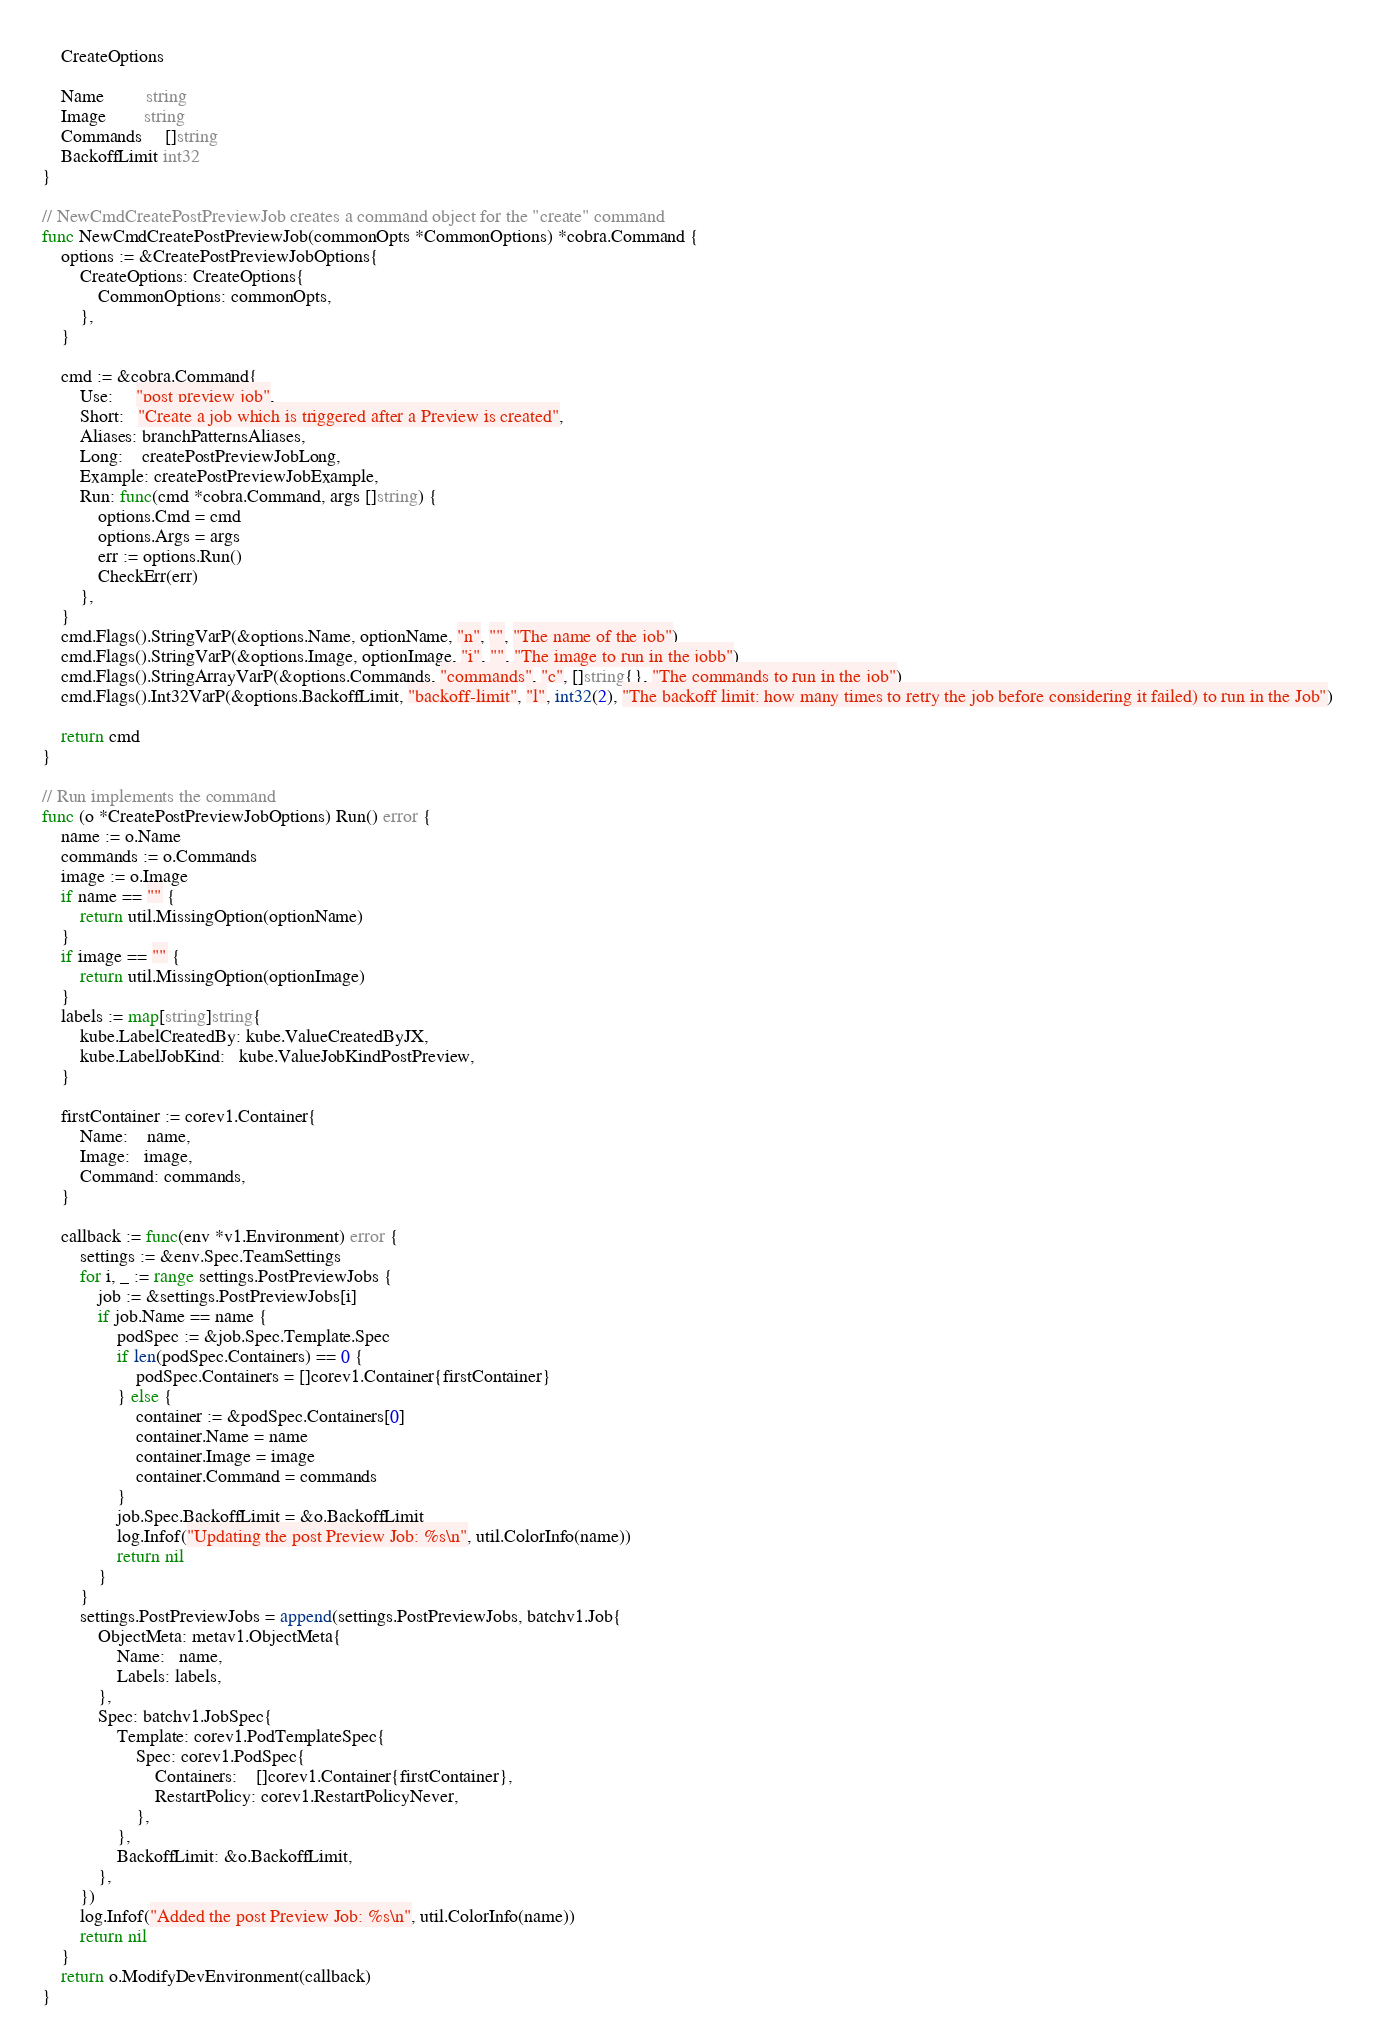Convert code to text. <code><loc_0><loc_0><loc_500><loc_500><_Go_>	CreateOptions

	Name         string
	Image        string
	Commands     []string
	BackoffLimit int32
}

// NewCmdCreatePostPreviewJob creates a command object for the "create" command
func NewCmdCreatePostPreviewJob(commonOpts *CommonOptions) *cobra.Command {
	options := &CreatePostPreviewJobOptions{
		CreateOptions: CreateOptions{
			CommonOptions: commonOpts,
		},
	}

	cmd := &cobra.Command{
		Use:     "post preview job",
		Short:   "Create a job which is triggered after a Preview is created",
		Aliases: branchPatternsAliases,
		Long:    createPostPreviewJobLong,
		Example: createPostPreviewJobExample,
		Run: func(cmd *cobra.Command, args []string) {
			options.Cmd = cmd
			options.Args = args
			err := options.Run()
			CheckErr(err)
		},
	}
	cmd.Flags().StringVarP(&options.Name, optionName, "n", "", "The name of the job")
	cmd.Flags().StringVarP(&options.Image, optionImage, "i", "", "The image to run in the jobb")
	cmd.Flags().StringArrayVarP(&options.Commands, "commands", "c", []string{}, "The commands to run in the job")
	cmd.Flags().Int32VarP(&options.BackoffLimit, "backoff-limit", "l", int32(2), "The backoff limit: how many times to retry the job before considering it failed) to run in the Job")

	return cmd
}

// Run implements the command
func (o *CreatePostPreviewJobOptions) Run() error {
	name := o.Name
	commands := o.Commands
	image := o.Image
	if name == "" {
		return util.MissingOption(optionName)
	}
	if image == "" {
		return util.MissingOption(optionImage)
	}
	labels := map[string]string{
		kube.LabelCreatedBy: kube.ValueCreatedByJX,
		kube.LabelJobKind:   kube.ValueJobKindPostPreview,
	}

	firstContainer := corev1.Container{
		Name:    name,
		Image:   image,
		Command: commands,
	}

	callback := func(env *v1.Environment) error {
		settings := &env.Spec.TeamSettings
		for i, _ := range settings.PostPreviewJobs {
			job := &settings.PostPreviewJobs[i]
			if job.Name == name {
				podSpec := &job.Spec.Template.Spec
				if len(podSpec.Containers) == 0 {
					podSpec.Containers = []corev1.Container{firstContainer}
				} else {
					container := &podSpec.Containers[0]
					container.Name = name
					container.Image = image
					container.Command = commands
				}
				job.Spec.BackoffLimit = &o.BackoffLimit
				log.Infof("Updating the post Preview Job: %s\n", util.ColorInfo(name))
				return nil
			}
		}
		settings.PostPreviewJobs = append(settings.PostPreviewJobs, batchv1.Job{
			ObjectMeta: metav1.ObjectMeta{
				Name:   name,
				Labels: labels,
			},
			Spec: batchv1.JobSpec{
				Template: corev1.PodTemplateSpec{
					Spec: corev1.PodSpec{
						Containers:    []corev1.Container{firstContainer},
						RestartPolicy: corev1.RestartPolicyNever,
					},
				},
				BackoffLimit: &o.BackoffLimit,
			},
		})
		log.Infof("Added the post Preview Job: %s\n", util.ColorInfo(name))
		return nil
	}
	return o.ModifyDevEnvironment(callback)
}
</code> 